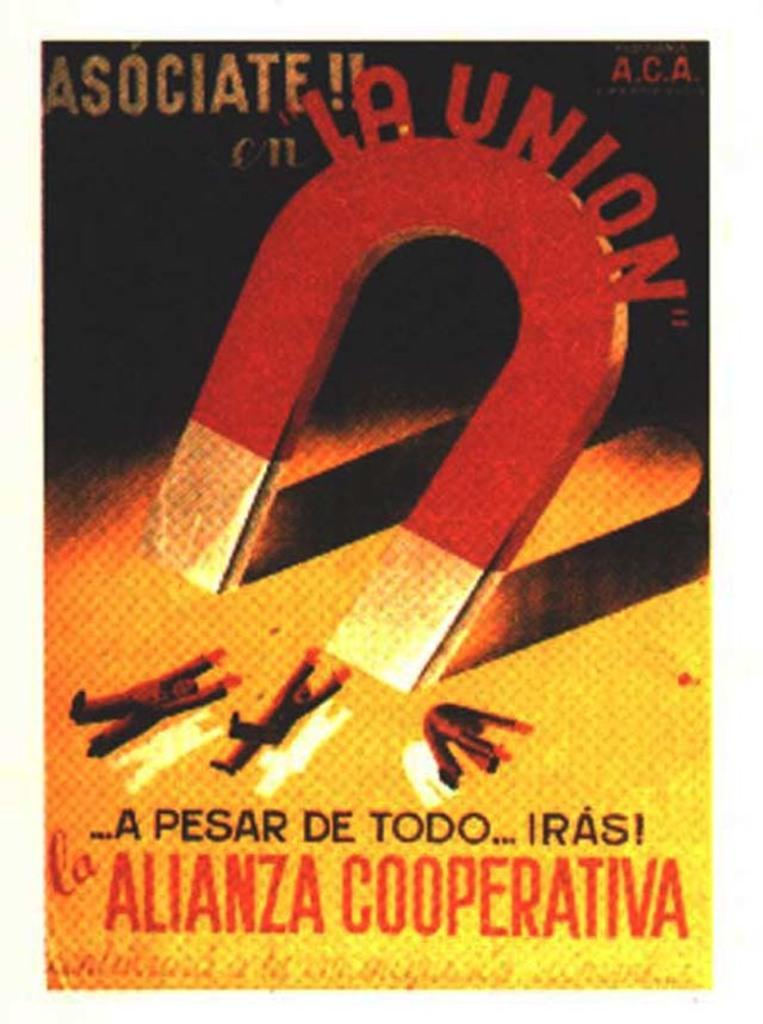<image>
Write a terse but informative summary of the picture. A flyer shows a magnet for LA Union pulling people towards it in a hurtful manner. 